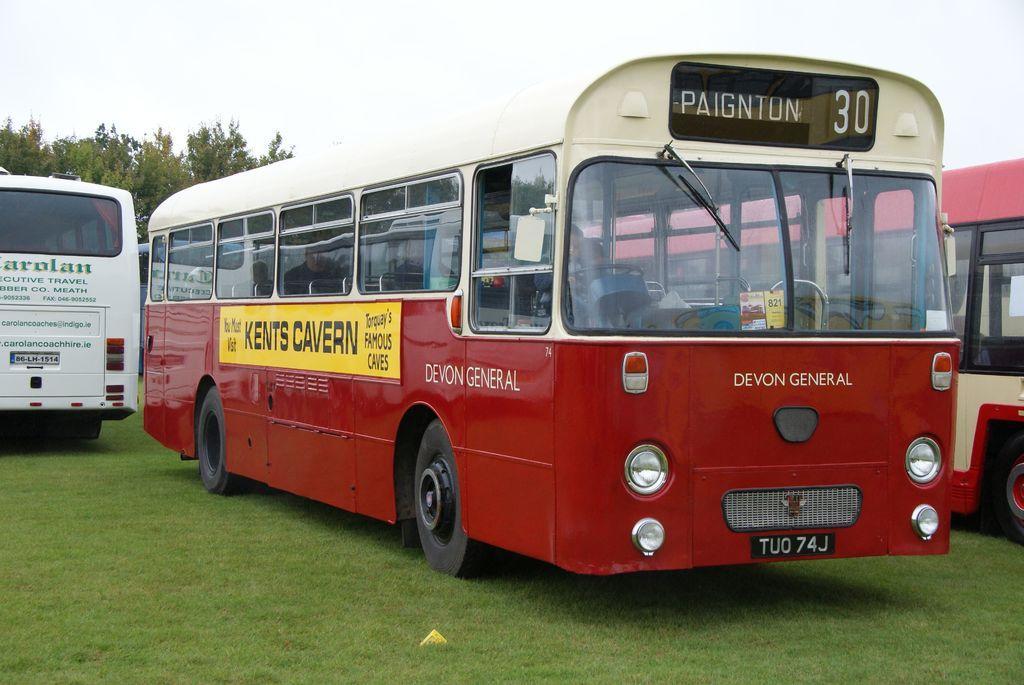Can you describe this image briefly? We can see buses on the grass. In the background we can see trees and sky. 